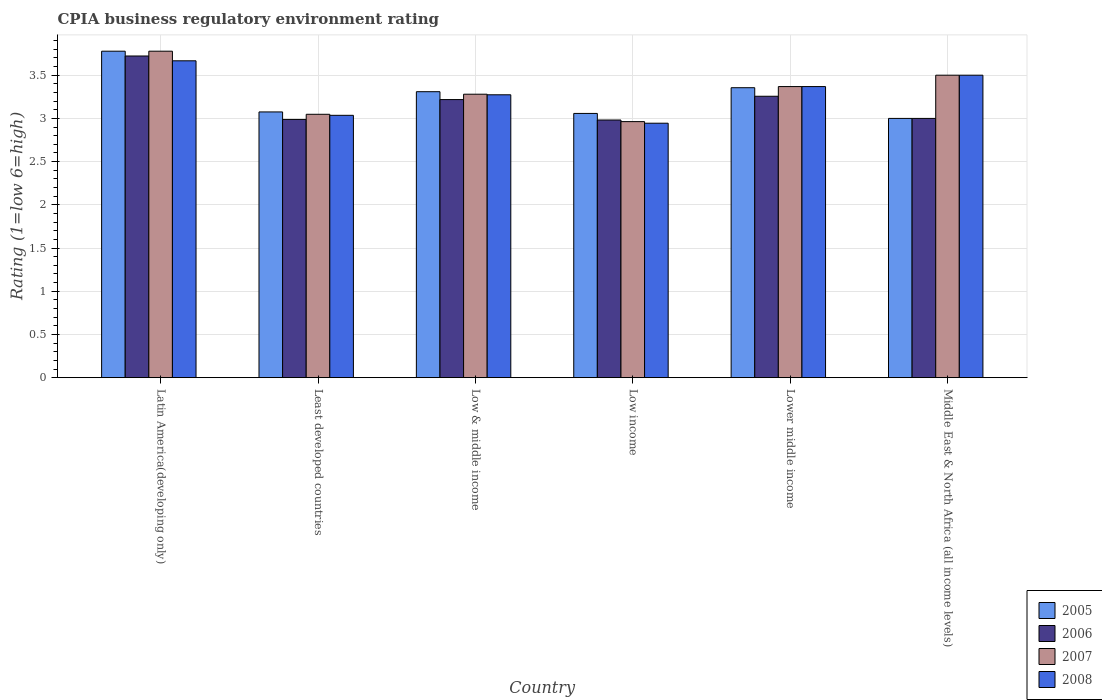How many groups of bars are there?
Your response must be concise. 6. Are the number of bars per tick equal to the number of legend labels?
Provide a succinct answer. Yes. What is the label of the 5th group of bars from the left?
Keep it short and to the point. Lower middle income. Across all countries, what is the maximum CPIA rating in 2006?
Give a very brief answer. 3.72. Across all countries, what is the minimum CPIA rating in 2007?
Ensure brevity in your answer.  2.96. In which country was the CPIA rating in 2005 maximum?
Keep it short and to the point. Latin America(developing only). In which country was the CPIA rating in 2006 minimum?
Offer a very short reply. Low income. What is the total CPIA rating in 2005 in the graph?
Your answer should be compact. 19.57. What is the difference between the CPIA rating in 2007 in Low & middle income and that in Low income?
Offer a very short reply. 0.32. What is the difference between the CPIA rating in 2006 in Middle East & North Africa (all income levels) and the CPIA rating in 2008 in Least developed countries?
Keep it short and to the point. -0.04. What is the average CPIA rating in 2006 per country?
Offer a terse response. 3.19. What is the difference between the CPIA rating of/in 2005 and CPIA rating of/in 2008 in Least developed countries?
Give a very brief answer. 0.04. In how many countries, is the CPIA rating in 2007 greater than 1.3?
Your response must be concise. 6. What is the ratio of the CPIA rating in 2008 in Latin America(developing only) to that in Low & middle income?
Give a very brief answer. 1.12. What is the difference between the highest and the second highest CPIA rating in 2005?
Keep it short and to the point. -0.42. What is the difference between the highest and the lowest CPIA rating in 2007?
Make the answer very short. 0.81. Is the sum of the CPIA rating in 2008 in Low income and Middle East & North Africa (all income levels) greater than the maximum CPIA rating in 2005 across all countries?
Give a very brief answer. Yes. Is it the case that in every country, the sum of the CPIA rating in 2008 and CPIA rating in 2006 is greater than the sum of CPIA rating in 2005 and CPIA rating in 2007?
Offer a terse response. No. Is it the case that in every country, the sum of the CPIA rating in 2007 and CPIA rating in 2005 is greater than the CPIA rating in 2008?
Your answer should be very brief. Yes. How many bars are there?
Your answer should be compact. 24. What is the difference between two consecutive major ticks on the Y-axis?
Your answer should be compact. 0.5. Does the graph contain any zero values?
Your answer should be very brief. No. How are the legend labels stacked?
Provide a succinct answer. Vertical. What is the title of the graph?
Give a very brief answer. CPIA business regulatory environment rating. Does "1965" appear as one of the legend labels in the graph?
Ensure brevity in your answer.  No. What is the label or title of the Y-axis?
Provide a succinct answer. Rating (1=low 6=high). What is the Rating (1=low 6=high) in 2005 in Latin America(developing only)?
Ensure brevity in your answer.  3.78. What is the Rating (1=low 6=high) in 2006 in Latin America(developing only)?
Give a very brief answer. 3.72. What is the Rating (1=low 6=high) of 2007 in Latin America(developing only)?
Offer a terse response. 3.78. What is the Rating (1=low 6=high) in 2008 in Latin America(developing only)?
Provide a short and direct response. 3.67. What is the Rating (1=low 6=high) of 2005 in Least developed countries?
Your answer should be compact. 3.08. What is the Rating (1=low 6=high) in 2006 in Least developed countries?
Your answer should be very brief. 2.99. What is the Rating (1=low 6=high) in 2007 in Least developed countries?
Ensure brevity in your answer.  3.05. What is the Rating (1=low 6=high) in 2008 in Least developed countries?
Your answer should be compact. 3.04. What is the Rating (1=low 6=high) of 2005 in Low & middle income?
Your response must be concise. 3.31. What is the Rating (1=low 6=high) of 2006 in Low & middle income?
Provide a succinct answer. 3.22. What is the Rating (1=low 6=high) in 2007 in Low & middle income?
Your answer should be compact. 3.28. What is the Rating (1=low 6=high) in 2008 in Low & middle income?
Offer a very short reply. 3.27. What is the Rating (1=low 6=high) of 2005 in Low income?
Provide a short and direct response. 3.06. What is the Rating (1=low 6=high) of 2006 in Low income?
Offer a very short reply. 2.98. What is the Rating (1=low 6=high) in 2007 in Low income?
Give a very brief answer. 2.96. What is the Rating (1=low 6=high) of 2008 in Low income?
Ensure brevity in your answer.  2.94. What is the Rating (1=low 6=high) in 2005 in Lower middle income?
Keep it short and to the point. 3.36. What is the Rating (1=low 6=high) in 2006 in Lower middle income?
Offer a terse response. 3.26. What is the Rating (1=low 6=high) of 2007 in Lower middle income?
Your answer should be very brief. 3.37. What is the Rating (1=low 6=high) of 2008 in Lower middle income?
Ensure brevity in your answer.  3.37. What is the Rating (1=low 6=high) in 2005 in Middle East & North Africa (all income levels)?
Offer a terse response. 3. What is the Rating (1=low 6=high) in 2006 in Middle East & North Africa (all income levels)?
Ensure brevity in your answer.  3. What is the Rating (1=low 6=high) of 2007 in Middle East & North Africa (all income levels)?
Offer a very short reply. 3.5. Across all countries, what is the maximum Rating (1=low 6=high) in 2005?
Give a very brief answer. 3.78. Across all countries, what is the maximum Rating (1=low 6=high) of 2006?
Your answer should be very brief. 3.72. Across all countries, what is the maximum Rating (1=low 6=high) of 2007?
Provide a short and direct response. 3.78. Across all countries, what is the maximum Rating (1=low 6=high) of 2008?
Provide a short and direct response. 3.67. Across all countries, what is the minimum Rating (1=low 6=high) in 2005?
Offer a very short reply. 3. Across all countries, what is the minimum Rating (1=low 6=high) in 2006?
Your answer should be compact. 2.98. Across all countries, what is the minimum Rating (1=low 6=high) of 2007?
Make the answer very short. 2.96. Across all countries, what is the minimum Rating (1=low 6=high) of 2008?
Offer a very short reply. 2.94. What is the total Rating (1=low 6=high) in 2005 in the graph?
Your response must be concise. 19.57. What is the total Rating (1=low 6=high) of 2006 in the graph?
Your answer should be compact. 19.17. What is the total Rating (1=low 6=high) of 2007 in the graph?
Provide a short and direct response. 19.94. What is the total Rating (1=low 6=high) of 2008 in the graph?
Give a very brief answer. 19.79. What is the difference between the Rating (1=low 6=high) in 2005 in Latin America(developing only) and that in Least developed countries?
Ensure brevity in your answer.  0.7. What is the difference between the Rating (1=low 6=high) of 2006 in Latin America(developing only) and that in Least developed countries?
Offer a very short reply. 0.73. What is the difference between the Rating (1=low 6=high) in 2007 in Latin America(developing only) and that in Least developed countries?
Your answer should be very brief. 0.73. What is the difference between the Rating (1=low 6=high) of 2008 in Latin America(developing only) and that in Least developed countries?
Provide a succinct answer. 0.63. What is the difference between the Rating (1=low 6=high) of 2005 in Latin America(developing only) and that in Low & middle income?
Give a very brief answer. 0.47. What is the difference between the Rating (1=low 6=high) in 2006 in Latin America(developing only) and that in Low & middle income?
Offer a very short reply. 0.5. What is the difference between the Rating (1=low 6=high) in 2007 in Latin America(developing only) and that in Low & middle income?
Offer a terse response. 0.5. What is the difference between the Rating (1=low 6=high) of 2008 in Latin America(developing only) and that in Low & middle income?
Keep it short and to the point. 0.39. What is the difference between the Rating (1=low 6=high) in 2005 in Latin America(developing only) and that in Low income?
Provide a short and direct response. 0.72. What is the difference between the Rating (1=low 6=high) in 2006 in Latin America(developing only) and that in Low income?
Your response must be concise. 0.74. What is the difference between the Rating (1=low 6=high) of 2007 in Latin America(developing only) and that in Low income?
Keep it short and to the point. 0.81. What is the difference between the Rating (1=low 6=high) in 2008 in Latin America(developing only) and that in Low income?
Give a very brief answer. 0.72. What is the difference between the Rating (1=low 6=high) of 2005 in Latin America(developing only) and that in Lower middle income?
Keep it short and to the point. 0.42. What is the difference between the Rating (1=low 6=high) in 2006 in Latin America(developing only) and that in Lower middle income?
Provide a short and direct response. 0.47. What is the difference between the Rating (1=low 6=high) in 2007 in Latin America(developing only) and that in Lower middle income?
Keep it short and to the point. 0.41. What is the difference between the Rating (1=low 6=high) in 2008 in Latin America(developing only) and that in Lower middle income?
Provide a short and direct response. 0.3. What is the difference between the Rating (1=low 6=high) of 2006 in Latin America(developing only) and that in Middle East & North Africa (all income levels)?
Make the answer very short. 0.72. What is the difference between the Rating (1=low 6=high) of 2007 in Latin America(developing only) and that in Middle East & North Africa (all income levels)?
Ensure brevity in your answer.  0.28. What is the difference between the Rating (1=low 6=high) in 2008 in Latin America(developing only) and that in Middle East & North Africa (all income levels)?
Give a very brief answer. 0.17. What is the difference between the Rating (1=low 6=high) in 2005 in Least developed countries and that in Low & middle income?
Your answer should be very brief. -0.23. What is the difference between the Rating (1=low 6=high) of 2006 in Least developed countries and that in Low & middle income?
Offer a terse response. -0.23. What is the difference between the Rating (1=low 6=high) of 2007 in Least developed countries and that in Low & middle income?
Offer a very short reply. -0.23. What is the difference between the Rating (1=low 6=high) of 2008 in Least developed countries and that in Low & middle income?
Provide a short and direct response. -0.24. What is the difference between the Rating (1=low 6=high) in 2005 in Least developed countries and that in Low income?
Offer a terse response. 0.02. What is the difference between the Rating (1=low 6=high) in 2006 in Least developed countries and that in Low income?
Your answer should be compact. 0.01. What is the difference between the Rating (1=low 6=high) in 2007 in Least developed countries and that in Low income?
Your answer should be very brief. 0.08. What is the difference between the Rating (1=low 6=high) in 2008 in Least developed countries and that in Low income?
Your answer should be compact. 0.09. What is the difference between the Rating (1=low 6=high) of 2005 in Least developed countries and that in Lower middle income?
Your response must be concise. -0.28. What is the difference between the Rating (1=low 6=high) in 2006 in Least developed countries and that in Lower middle income?
Your answer should be compact. -0.27. What is the difference between the Rating (1=low 6=high) of 2007 in Least developed countries and that in Lower middle income?
Keep it short and to the point. -0.32. What is the difference between the Rating (1=low 6=high) in 2008 in Least developed countries and that in Lower middle income?
Ensure brevity in your answer.  -0.33. What is the difference between the Rating (1=low 6=high) of 2005 in Least developed countries and that in Middle East & North Africa (all income levels)?
Make the answer very short. 0.07. What is the difference between the Rating (1=low 6=high) of 2006 in Least developed countries and that in Middle East & North Africa (all income levels)?
Give a very brief answer. -0.01. What is the difference between the Rating (1=low 6=high) in 2007 in Least developed countries and that in Middle East & North Africa (all income levels)?
Make the answer very short. -0.45. What is the difference between the Rating (1=low 6=high) of 2008 in Least developed countries and that in Middle East & North Africa (all income levels)?
Your answer should be compact. -0.46. What is the difference between the Rating (1=low 6=high) of 2005 in Low & middle income and that in Low income?
Make the answer very short. 0.25. What is the difference between the Rating (1=low 6=high) in 2006 in Low & middle income and that in Low income?
Make the answer very short. 0.24. What is the difference between the Rating (1=low 6=high) of 2007 in Low & middle income and that in Low income?
Your answer should be compact. 0.32. What is the difference between the Rating (1=low 6=high) of 2008 in Low & middle income and that in Low income?
Your response must be concise. 0.33. What is the difference between the Rating (1=low 6=high) of 2005 in Low & middle income and that in Lower middle income?
Provide a succinct answer. -0.05. What is the difference between the Rating (1=low 6=high) in 2006 in Low & middle income and that in Lower middle income?
Offer a terse response. -0.04. What is the difference between the Rating (1=low 6=high) of 2007 in Low & middle income and that in Lower middle income?
Your answer should be very brief. -0.09. What is the difference between the Rating (1=low 6=high) in 2008 in Low & middle income and that in Lower middle income?
Provide a short and direct response. -0.1. What is the difference between the Rating (1=low 6=high) of 2005 in Low & middle income and that in Middle East & North Africa (all income levels)?
Provide a short and direct response. 0.31. What is the difference between the Rating (1=low 6=high) of 2006 in Low & middle income and that in Middle East & North Africa (all income levels)?
Make the answer very short. 0.22. What is the difference between the Rating (1=low 6=high) in 2007 in Low & middle income and that in Middle East & North Africa (all income levels)?
Give a very brief answer. -0.22. What is the difference between the Rating (1=low 6=high) of 2008 in Low & middle income and that in Middle East & North Africa (all income levels)?
Make the answer very short. -0.23. What is the difference between the Rating (1=low 6=high) in 2005 in Low income and that in Lower middle income?
Keep it short and to the point. -0.3. What is the difference between the Rating (1=low 6=high) of 2006 in Low income and that in Lower middle income?
Provide a succinct answer. -0.27. What is the difference between the Rating (1=low 6=high) in 2007 in Low income and that in Lower middle income?
Provide a succinct answer. -0.41. What is the difference between the Rating (1=low 6=high) of 2008 in Low income and that in Lower middle income?
Make the answer very short. -0.42. What is the difference between the Rating (1=low 6=high) of 2005 in Low income and that in Middle East & North Africa (all income levels)?
Offer a very short reply. 0.06. What is the difference between the Rating (1=low 6=high) in 2006 in Low income and that in Middle East & North Africa (all income levels)?
Offer a very short reply. -0.02. What is the difference between the Rating (1=low 6=high) in 2007 in Low income and that in Middle East & North Africa (all income levels)?
Provide a short and direct response. -0.54. What is the difference between the Rating (1=low 6=high) in 2008 in Low income and that in Middle East & North Africa (all income levels)?
Offer a terse response. -0.56. What is the difference between the Rating (1=low 6=high) in 2005 in Lower middle income and that in Middle East & North Africa (all income levels)?
Make the answer very short. 0.36. What is the difference between the Rating (1=low 6=high) of 2006 in Lower middle income and that in Middle East & North Africa (all income levels)?
Make the answer very short. 0.26. What is the difference between the Rating (1=low 6=high) in 2007 in Lower middle income and that in Middle East & North Africa (all income levels)?
Your answer should be very brief. -0.13. What is the difference between the Rating (1=low 6=high) in 2008 in Lower middle income and that in Middle East & North Africa (all income levels)?
Your answer should be compact. -0.13. What is the difference between the Rating (1=low 6=high) in 2005 in Latin America(developing only) and the Rating (1=low 6=high) in 2006 in Least developed countries?
Provide a succinct answer. 0.79. What is the difference between the Rating (1=low 6=high) of 2005 in Latin America(developing only) and the Rating (1=low 6=high) of 2007 in Least developed countries?
Offer a terse response. 0.73. What is the difference between the Rating (1=low 6=high) in 2005 in Latin America(developing only) and the Rating (1=low 6=high) in 2008 in Least developed countries?
Your response must be concise. 0.74. What is the difference between the Rating (1=low 6=high) of 2006 in Latin America(developing only) and the Rating (1=low 6=high) of 2007 in Least developed countries?
Provide a short and direct response. 0.67. What is the difference between the Rating (1=low 6=high) of 2006 in Latin America(developing only) and the Rating (1=low 6=high) of 2008 in Least developed countries?
Offer a terse response. 0.69. What is the difference between the Rating (1=low 6=high) of 2007 in Latin America(developing only) and the Rating (1=low 6=high) of 2008 in Least developed countries?
Your response must be concise. 0.74. What is the difference between the Rating (1=low 6=high) of 2005 in Latin America(developing only) and the Rating (1=low 6=high) of 2006 in Low & middle income?
Keep it short and to the point. 0.56. What is the difference between the Rating (1=low 6=high) in 2005 in Latin America(developing only) and the Rating (1=low 6=high) in 2007 in Low & middle income?
Offer a terse response. 0.5. What is the difference between the Rating (1=low 6=high) in 2005 in Latin America(developing only) and the Rating (1=low 6=high) in 2008 in Low & middle income?
Your response must be concise. 0.5. What is the difference between the Rating (1=low 6=high) of 2006 in Latin America(developing only) and the Rating (1=low 6=high) of 2007 in Low & middle income?
Your response must be concise. 0.44. What is the difference between the Rating (1=low 6=high) of 2006 in Latin America(developing only) and the Rating (1=low 6=high) of 2008 in Low & middle income?
Provide a short and direct response. 0.45. What is the difference between the Rating (1=low 6=high) in 2007 in Latin America(developing only) and the Rating (1=low 6=high) in 2008 in Low & middle income?
Give a very brief answer. 0.5. What is the difference between the Rating (1=low 6=high) of 2005 in Latin America(developing only) and the Rating (1=low 6=high) of 2006 in Low income?
Offer a very short reply. 0.8. What is the difference between the Rating (1=low 6=high) of 2005 in Latin America(developing only) and the Rating (1=low 6=high) of 2007 in Low income?
Offer a terse response. 0.81. What is the difference between the Rating (1=low 6=high) in 2006 in Latin America(developing only) and the Rating (1=low 6=high) in 2007 in Low income?
Your answer should be compact. 0.76. What is the difference between the Rating (1=low 6=high) of 2007 in Latin America(developing only) and the Rating (1=low 6=high) of 2008 in Low income?
Offer a very short reply. 0.83. What is the difference between the Rating (1=low 6=high) of 2005 in Latin America(developing only) and the Rating (1=low 6=high) of 2006 in Lower middle income?
Offer a terse response. 0.52. What is the difference between the Rating (1=low 6=high) of 2005 in Latin America(developing only) and the Rating (1=low 6=high) of 2007 in Lower middle income?
Your answer should be compact. 0.41. What is the difference between the Rating (1=low 6=high) in 2005 in Latin America(developing only) and the Rating (1=low 6=high) in 2008 in Lower middle income?
Your response must be concise. 0.41. What is the difference between the Rating (1=low 6=high) in 2006 in Latin America(developing only) and the Rating (1=low 6=high) in 2007 in Lower middle income?
Your answer should be very brief. 0.35. What is the difference between the Rating (1=low 6=high) of 2006 in Latin America(developing only) and the Rating (1=low 6=high) of 2008 in Lower middle income?
Give a very brief answer. 0.35. What is the difference between the Rating (1=low 6=high) of 2007 in Latin America(developing only) and the Rating (1=low 6=high) of 2008 in Lower middle income?
Provide a succinct answer. 0.41. What is the difference between the Rating (1=low 6=high) of 2005 in Latin America(developing only) and the Rating (1=low 6=high) of 2006 in Middle East & North Africa (all income levels)?
Make the answer very short. 0.78. What is the difference between the Rating (1=low 6=high) of 2005 in Latin America(developing only) and the Rating (1=low 6=high) of 2007 in Middle East & North Africa (all income levels)?
Give a very brief answer. 0.28. What is the difference between the Rating (1=low 6=high) in 2005 in Latin America(developing only) and the Rating (1=low 6=high) in 2008 in Middle East & North Africa (all income levels)?
Give a very brief answer. 0.28. What is the difference between the Rating (1=low 6=high) in 2006 in Latin America(developing only) and the Rating (1=low 6=high) in 2007 in Middle East & North Africa (all income levels)?
Keep it short and to the point. 0.22. What is the difference between the Rating (1=low 6=high) of 2006 in Latin America(developing only) and the Rating (1=low 6=high) of 2008 in Middle East & North Africa (all income levels)?
Offer a very short reply. 0.22. What is the difference between the Rating (1=low 6=high) of 2007 in Latin America(developing only) and the Rating (1=low 6=high) of 2008 in Middle East & North Africa (all income levels)?
Your answer should be compact. 0.28. What is the difference between the Rating (1=low 6=high) in 2005 in Least developed countries and the Rating (1=low 6=high) in 2006 in Low & middle income?
Your response must be concise. -0.14. What is the difference between the Rating (1=low 6=high) of 2005 in Least developed countries and the Rating (1=low 6=high) of 2007 in Low & middle income?
Ensure brevity in your answer.  -0.2. What is the difference between the Rating (1=low 6=high) of 2005 in Least developed countries and the Rating (1=low 6=high) of 2008 in Low & middle income?
Your response must be concise. -0.2. What is the difference between the Rating (1=low 6=high) in 2006 in Least developed countries and the Rating (1=low 6=high) in 2007 in Low & middle income?
Offer a terse response. -0.29. What is the difference between the Rating (1=low 6=high) in 2006 in Least developed countries and the Rating (1=low 6=high) in 2008 in Low & middle income?
Provide a succinct answer. -0.29. What is the difference between the Rating (1=low 6=high) of 2007 in Least developed countries and the Rating (1=low 6=high) of 2008 in Low & middle income?
Keep it short and to the point. -0.23. What is the difference between the Rating (1=low 6=high) in 2005 in Least developed countries and the Rating (1=low 6=high) in 2006 in Low income?
Make the answer very short. 0.09. What is the difference between the Rating (1=low 6=high) of 2005 in Least developed countries and the Rating (1=low 6=high) of 2007 in Low income?
Your answer should be very brief. 0.11. What is the difference between the Rating (1=low 6=high) in 2005 in Least developed countries and the Rating (1=low 6=high) in 2008 in Low income?
Offer a terse response. 0.13. What is the difference between the Rating (1=low 6=high) of 2006 in Least developed countries and the Rating (1=low 6=high) of 2007 in Low income?
Make the answer very short. 0.03. What is the difference between the Rating (1=low 6=high) in 2006 in Least developed countries and the Rating (1=low 6=high) in 2008 in Low income?
Keep it short and to the point. 0.04. What is the difference between the Rating (1=low 6=high) of 2007 in Least developed countries and the Rating (1=low 6=high) of 2008 in Low income?
Provide a succinct answer. 0.1. What is the difference between the Rating (1=low 6=high) in 2005 in Least developed countries and the Rating (1=low 6=high) in 2006 in Lower middle income?
Provide a succinct answer. -0.18. What is the difference between the Rating (1=low 6=high) in 2005 in Least developed countries and the Rating (1=low 6=high) in 2007 in Lower middle income?
Provide a succinct answer. -0.29. What is the difference between the Rating (1=low 6=high) in 2005 in Least developed countries and the Rating (1=low 6=high) in 2008 in Lower middle income?
Provide a succinct answer. -0.29. What is the difference between the Rating (1=low 6=high) in 2006 in Least developed countries and the Rating (1=low 6=high) in 2007 in Lower middle income?
Give a very brief answer. -0.38. What is the difference between the Rating (1=low 6=high) of 2006 in Least developed countries and the Rating (1=low 6=high) of 2008 in Lower middle income?
Offer a terse response. -0.38. What is the difference between the Rating (1=low 6=high) of 2007 in Least developed countries and the Rating (1=low 6=high) of 2008 in Lower middle income?
Make the answer very short. -0.32. What is the difference between the Rating (1=low 6=high) of 2005 in Least developed countries and the Rating (1=low 6=high) of 2006 in Middle East & North Africa (all income levels)?
Provide a succinct answer. 0.07. What is the difference between the Rating (1=low 6=high) in 2005 in Least developed countries and the Rating (1=low 6=high) in 2007 in Middle East & North Africa (all income levels)?
Make the answer very short. -0.42. What is the difference between the Rating (1=low 6=high) in 2005 in Least developed countries and the Rating (1=low 6=high) in 2008 in Middle East & North Africa (all income levels)?
Make the answer very short. -0.42. What is the difference between the Rating (1=low 6=high) in 2006 in Least developed countries and the Rating (1=low 6=high) in 2007 in Middle East & North Africa (all income levels)?
Ensure brevity in your answer.  -0.51. What is the difference between the Rating (1=low 6=high) in 2006 in Least developed countries and the Rating (1=low 6=high) in 2008 in Middle East & North Africa (all income levels)?
Your response must be concise. -0.51. What is the difference between the Rating (1=low 6=high) of 2007 in Least developed countries and the Rating (1=low 6=high) of 2008 in Middle East & North Africa (all income levels)?
Your response must be concise. -0.45. What is the difference between the Rating (1=low 6=high) of 2005 in Low & middle income and the Rating (1=low 6=high) of 2006 in Low income?
Your response must be concise. 0.33. What is the difference between the Rating (1=low 6=high) of 2005 in Low & middle income and the Rating (1=low 6=high) of 2007 in Low income?
Ensure brevity in your answer.  0.35. What is the difference between the Rating (1=low 6=high) in 2005 in Low & middle income and the Rating (1=low 6=high) in 2008 in Low income?
Keep it short and to the point. 0.36. What is the difference between the Rating (1=low 6=high) in 2006 in Low & middle income and the Rating (1=low 6=high) in 2007 in Low income?
Give a very brief answer. 0.26. What is the difference between the Rating (1=low 6=high) in 2006 in Low & middle income and the Rating (1=low 6=high) in 2008 in Low income?
Provide a short and direct response. 0.27. What is the difference between the Rating (1=low 6=high) of 2007 in Low & middle income and the Rating (1=low 6=high) of 2008 in Low income?
Your answer should be very brief. 0.34. What is the difference between the Rating (1=low 6=high) in 2005 in Low & middle income and the Rating (1=low 6=high) in 2006 in Lower middle income?
Your answer should be very brief. 0.05. What is the difference between the Rating (1=low 6=high) in 2005 in Low & middle income and the Rating (1=low 6=high) in 2007 in Lower middle income?
Make the answer very short. -0.06. What is the difference between the Rating (1=low 6=high) in 2005 in Low & middle income and the Rating (1=low 6=high) in 2008 in Lower middle income?
Provide a succinct answer. -0.06. What is the difference between the Rating (1=low 6=high) in 2006 in Low & middle income and the Rating (1=low 6=high) in 2007 in Lower middle income?
Your answer should be very brief. -0.15. What is the difference between the Rating (1=low 6=high) of 2006 in Low & middle income and the Rating (1=low 6=high) of 2008 in Lower middle income?
Give a very brief answer. -0.15. What is the difference between the Rating (1=low 6=high) of 2007 in Low & middle income and the Rating (1=low 6=high) of 2008 in Lower middle income?
Offer a very short reply. -0.09. What is the difference between the Rating (1=low 6=high) of 2005 in Low & middle income and the Rating (1=low 6=high) of 2006 in Middle East & North Africa (all income levels)?
Offer a very short reply. 0.31. What is the difference between the Rating (1=low 6=high) in 2005 in Low & middle income and the Rating (1=low 6=high) in 2007 in Middle East & North Africa (all income levels)?
Offer a very short reply. -0.19. What is the difference between the Rating (1=low 6=high) of 2005 in Low & middle income and the Rating (1=low 6=high) of 2008 in Middle East & North Africa (all income levels)?
Offer a terse response. -0.19. What is the difference between the Rating (1=low 6=high) in 2006 in Low & middle income and the Rating (1=low 6=high) in 2007 in Middle East & North Africa (all income levels)?
Make the answer very short. -0.28. What is the difference between the Rating (1=low 6=high) of 2006 in Low & middle income and the Rating (1=low 6=high) of 2008 in Middle East & North Africa (all income levels)?
Your answer should be compact. -0.28. What is the difference between the Rating (1=low 6=high) in 2007 in Low & middle income and the Rating (1=low 6=high) in 2008 in Middle East & North Africa (all income levels)?
Offer a terse response. -0.22. What is the difference between the Rating (1=low 6=high) in 2005 in Low income and the Rating (1=low 6=high) in 2006 in Lower middle income?
Ensure brevity in your answer.  -0.2. What is the difference between the Rating (1=low 6=high) in 2005 in Low income and the Rating (1=low 6=high) in 2007 in Lower middle income?
Your answer should be very brief. -0.31. What is the difference between the Rating (1=low 6=high) of 2005 in Low income and the Rating (1=low 6=high) of 2008 in Lower middle income?
Ensure brevity in your answer.  -0.31. What is the difference between the Rating (1=low 6=high) in 2006 in Low income and the Rating (1=low 6=high) in 2007 in Lower middle income?
Offer a very short reply. -0.39. What is the difference between the Rating (1=low 6=high) in 2006 in Low income and the Rating (1=low 6=high) in 2008 in Lower middle income?
Provide a succinct answer. -0.39. What is the difference between the Rating (1=low 6=high) of 2007 in Low income and the Rating (1=low 6=high) of 2008 in Lower middle income?
Keep it short and to the point. -0.41. What is the difference between the Rating (1=low 6=high) in 2005 in Low income and the Rating (1=low 6=high) in 2006 in Middle East & North Africa (all income levels)?
Your answer should be compact. 0.06. What is the difference between the Rating (1=low 6=high) of 2005 in Low income and the Rating (1=low 6=high) of 2007 in Middle East & North Africa (all income levels)?
Your response must be concise. -0.44. What is the difference between the Rating (1=low 6=high) in 2005 in Low income and the Rating (1=low 6=high) in 2008 in Middle East & North Africa (all income levels)?
Offer a terse response. -0.44. What is the difference between the Rating (1=low 6=high) in 2006 in Low income and the Rating (1=low 6=high) in 2007 in Middle East & North Africa (all income levels)?
Provide a succinct answer. -0.52. What is the difference between the Rating (1=low 6=high) of 2006 in Low income and the Rating (1=low 6=high) of 2008 in Middle East & North Africa (all income levels)?
Ensure brevity in your answer.  -0.52. What is the difference between the Rating (1=low 6=high) in 2007 in Low income and the Rating (1=low 6=high) in 2008 in Middle East & North Africa (all income levels)?
Give a very brief answer. -0.54. What is the difference between the Rating (1=low 6=high) of 2005 in Lower middle income and the Rating (1=low 6=high) of 2006 in Middle East & North Africa (all income levels)?
Your answer should be compact. 0.36. What is the difference between the Rating (1=low 6=high) in 2005 in Lower middle income and the Rating (1=low 6=high) in 2007 in Middle East & North Africa (all income levels)?
Give a very brief answer. -0.14. What is the difference between the Rating (1=low 6=high) in 2005 in Lower middle income and the Rating (1=low 6=high) in 2008 in Middle East & North Africa (all income levels)?
Your answer should be compact. -0.14. What is the difference between the Rating (1=low 6=high) in 2006 in Lower middle income and the Rating (1=low 6=high) in 2007 in Middle East & North Africa (all income levels)?
Ensure brevity in your answer.  -0.24. What is the difference between the Rating (1=low 6=high) in 2006 in Lower middle income and the Rating (1=low 6=high) in 2008 in Middle East & North Africa (all income levels)?
Your answer should be very brief. -0.24. What is the difference between the Rating (1=low 6=high) in 2007 in Lower middle income and the Rating (1=low 6=high) in 2008 in Middle East & North Africa (all income levels)?
Your answer should be compact. -0.13. What is the average Rating (1=low 6=high) of 2005 per country?
Ensure brevity in your answer.  3.26. What is the average Rating (1=low 6=high) in 2006 per country?
Your response must be concise. 3.19. What is the average Rating (1=low 6=high) of 2007 per country?
Your answer should be very brief. 3.32. What is the average Rating (1=low 6=high) in 2008 per country?
Ensure brevity in your answer.  3.3. What is the difference between the Rating (1=low 6=high) of 2005 and Rating (1=low 6=high) of 2006 in Latin America(developing only)?
Keep it short and to the point. 0.06. What is the difference between the Rating (1=low 6=high) in 2006 and Rating (1=low 6=high) in 2007 in Latin America(developing only)?
Your answer should be compact. -0.06. What is the difference between the Rating (1=low 6=high) in 2006 and Rating (1=low 6=high) in 2008 in Latin America(developing only)?
Make the answer very short. 0.06. What is the difference between the Rating (1=low 6=high) in 2007 and Rating (1=low 6=high) in 2008 in Latin America(developing only)?
Keep it short and to the point. 0.11. What is the difference between the Rating (1=low 6=high) of 2005 and Rating (1=low 6=high) of 2006 in Least developed countries?
Make the answer very short. 0.09. What is the difference between the Rating (1=low 6=high) of 2005 and Rating (1=low 6=high) of 2007 in Least developed countries?
Your answer should be compact. 0.03. What is the difference between the Rating (1=low 6=high) in 2005 and Rating (1=low 6=high) in 2008 in Least developed countries?
Your answer should be very brief. 0.04. What is the difference between the Rating (1=low 6=high) in 2006 and Rating (1=low 6=high) in 2007 in Least developed countries?
Provide a succinct answer. -0.06. What is the difference between the Rating (1=low 6=high) in 2006 and Rating (1=low 6=high) in 2008 in Least developed countries?
Provide a succinct answer. -0.05. What is the difference between the Rating (1=low 6=high) in 2007 and Rating (1=low 6=high) in 2008 in Least developed countries?
Ensure brevity in your answer.  0.01. What is the difference between the Rating (1=low 6=high) in 2005 and Rating (1=low 6=high) in 2006 in Low & middle income?
Keep it short and to the point. 0.09. What is the difference between the Rating (1=low 6=high) of 2005 and Rating (1=low 6=high) of 2007 in Low & middle income?
Ensure brevity in your answer.  0.03. What is the difference between the Rating (1=low 6=high) in 2005 and Rating (1=low 6=high) in 2008 in Low & middle income?
Keep it short and to the point. 0.04. What is the difference between the Rating (1=low 6=high) of 2006 and Rating (1=low 6=high) of 2007 in Low & middle income?
Make the answer very short. -0.06. What is the difference between the Rating (1=low 6=high) in 2006 and Rating (1=low 6=high) in 2008 in Low & middle income?
Provide a succinct answer. -0.06. What is the difference between the Rating (1=low 6=high) in 2007 and Rating (1=low 6=high) in 2008 in Low & middle income?
Your response must be concise. 0.01. What is the difference between the Rating (1=low 6=high) in 2005 and Rating (1=low 6=high) in 2006 in Low income?
Provide a succinct answer. 0.08. What is the difference between the Rating (1=low 6=high) in 2005 and Rating (1=low 6=high) in 2007 in Low income?
Keep it short and to the point. 0.09. What is the difference between the Rating (1=low 6=high) of 2005 and Rating (1=low 6=high) of 2008 in Low income?
Give a very brief answer. 0.11. What is the difference between the Rating (1=low 6=high) of 2006 and Rating (1=low 6=high) of 2007 in Low income?
Your answer should be compact. 0.02. What is the difference between the Rating (1=low 6=high) of 2006 and Rating (1=low 6=high) of 2008 in Low income?
Offer a terse response. 0.04. What is the difference between the Rating (1=low 6=high) in 2007 and Rating (1=low 6=high) in 2008 in Low income?
Ensure brevity in your answer.  0.02. What is the difference between the Rating (1=low 6=high) in 2005 and Rating (1=low 6=high) in 2006 in Lower middle income?
Give a very brief answer. 0.1. What is the difference between the Rating (1=low 6=high) in 2005 and Rating (1=low 6=high) in 2007 in Lower middle income?
Your answer should be very brief. -0.01. What is the difference between the Rating (1=low 6=high) of 2005 and Rating (1=low 6=high) of 2008 in Lower middle income?
Your answer should be very brief. -0.01. What is the difference between the Rating (1=low 6=high) in 2006 and Rating (1=low 6=high) in 2007 in Lower middle income?
Your answer should be compact. -0.11. What is the difference between the Rating (1=low 6=high) of 2006 and Rating (1=low 6=high) of 2008 in Lower middle income?
Provide a short and direct response. -0.11. What is the difference between the Rating (1=low 6=high) in 2007 and Rating (1=low 6=high) in 2008 in Lower middle income?
Your answer should be very brief. 0. What is the difference between the Rating (1=low 6=high) in 2005 and Rating (1=low 6=high) in 2006 in Middle East & North Africa (all income levels)?
Provide a short and direct response. 0. What is the difference between the Rating (1=low 6=high) in 2005 and Rating (1=low 6=high) in 2008 in Middle East & North Africa (all income levels)?
Provide a short and direct response. -0.5. What is the ratio of the Rating (1=low 6=high) in 2005 in Latin America(developing only) to that in Least developed countries?
Your response must be concise. 1.23. What is the ratio of the Rating (1=low 6=high) in 2006 in Latin America(developing only) to that in Least developed countries?
Keep it short and to the point. 1.25. What is the ratio of the Rating (1=low 6=high) in 2007 in Latin America(developing only) to that in Least developed countries?
Offer a very short reply. 1.24. What is the ratio of the Rating (1=low 6=high) in 2008 in Latin America(developing only) to that in Least developed countries?
Offer a terse response. 1.21. What is the ratio of the Rating (1=low 6=high) in 2005 in Latin America(developing only) to that in Low & middle income?
Your answer should be compact. 1.14. What is the ratio of the Rating (1=low 6=high) in 2006 in Latin America(developing only) to that in Low & middle income?
Ensure brevity in your answer.  1.16. What is the ratio of the Rating (1=low 6=high) in 2007 in Latin America(developing only) to that in Low & middle income?
Give a very brief answer. 1.15. What is the ratio of the Rating (1=low 6=high) of 2008 in Latin America(developing only) to that in Low & middle income?
Offer a very short reply. 1.12. What is the ratio of the Rating (1=low 6=high) in 2005 in Latin America(developing only) to that in Low income?
Your answer should be compact. 1.24. What is the ratio of the Rating (1=low 6=high) in 2006 in Latin America(developing only) to that in Low income?
Provide a succinct answer. 1.25. What is the ratio of the Rating (1=low 6=high) in 2007 in Latin America(developing only) to that in Low income?
Ensure brevity in your answer.  1.27. What is the ratio of the Rating (1=low 6=high) of 2008 in Latin America(developing only) to that in Low income?
Give a very brief answer. 1.25. What is the ratio of the Rating (1=low 6=high) in 2005 in Latin America(developing only) to that in Lower middle income?
Offer a terse response. 1.13. What is the ratio of the Rating (1=low 6=high) of 2006 in Latin America(developing only) to that in Lower middle income?
Offer a terse response. 1.14. What is the ratio of the Rating (1=low 6=high) of 2007 in Latin America(developing only) to that in Lower middle income?
Provide a short and direct response. 1.12. What is the ratio of the Rating (1=low 6=high) in 2008 in Latin America(developing only) to that in Lower middle income?
Give a very brief answer. 1.09. What is the ratio of the Rating (1=low 6=high) in 2005 in Latin America(developing only) to that in Middle East & North Africa (all income levels)?
Ensure brevity in your answer.  1.26. What is the ratio of the Rating (1=low 6=high) in 2006 in Latin America(developing only) to that in Middle East & North Africa (all income levels)?
Make the answer very short. 1.24. What is the ratio of the Rating (1=low 6=high) of 2007 in Latin America(developing only) to that in Middle East & North Africa (all income levels)?
Provide a succinct answer. 1.08. What is the ratio of the Rating (1=low 6=high) in 2008 in Latin America(developing only) to that in Middle East & North Africa (all income levels)?
Offer a very short reply. 1.05. What is the ratio of the Rating (1=low 6=high) of 2005 in Least developed countries to that in Low & middle income?
Keep it short and to the point. 0.93. What is the ratio of the Rating (1=low 6=high) in 2006 in Least developed countries to that in Low & middle income?
Keep it short and to the point. 0.93. What is the ratio of the Rating (1=low 6=high) in 2007 in Least developed countries to that in Low & middle income?
Make the answer very short. 0.93. What is the ratio of the Rating (1=low 6=high) of 2008 in Least developed countries to that in Low & middle income?
Your answer should be very brief. 0.93. What is the ratio of the Rating (1=low 6=high) of 2007 in Least developed countries to that in Low income?
Offer a terse response. 1.03. What is the ratio of the Rating (1=low 6=high) in 2008 in Least developed countries to that in Low income?
Keep it short and to the point. 1.03. What is the ratio of the Rating (1=low 6=high) of 2005 in Least developed countries to that in Lower middle income?
Your answer should be compact. 0.92. What is the ratio of the Rating (1=low 6=high) in 2006 in Least developed countries to that in Lower middle income?
Give a very brief answer. 0.92. What is the ratio of the Rating (1=low 6=high) of 2007 in Least developed countries to that in Lower middle income?
Offer a very short reply. 0.9. What is the ratio of the Rating (1=low 6=high) of 2008 in Least developed countries to that in Lower middle income?
Your response must be concise. 0.9. What is the ratio of the Rating (1=low 6=high) of 2007 in Least developed countries to that in Middle East & North Africa (all income levels)?
Offer a very short reply. 0.87. What is the ratio of the Rating (1=low 6=high) of 2008 in Least developed countries to that in Middle East & North Africa (all income levels)?
Offer a terse response. 0.87. What is the ratio of the Rating (1=low 6=high) in 2005 in Low & middle income to that in Low income?
Ensure brevity in your answer.  1.08. What is the ratio of the Rating (1=low 6=high) in 2006 in Low & middle income to that in Low income?
Give a very brief answer. 1.08. What is the ratio of the Rating (1=low 6=high) of 2007 in Low & middle income to that in Low income?
Provide a short and direct response. 1.11. What is the ratio of the Rating (1=low 6=high) in 2008 in Low & middle income to that in Low income?
Provide a succinct answer. 1.11. What is the ratio of the Rating (1=low 6=high) of 2005 in Low & middle income to that in Lower middle income?
Your answer should be compact. 0.99. What is the ratio of the Rating (1=low 6=high) in 2006 in Low & middle income to that in Lower middle income?
Keep it short and to the point. 0.99. What is the ratio of the Rating (1=low 6=high) of 2007 in Low & middle income to that in Lower middle income?
Keep it short and to the point. 0.97. What is the ratio of the Rating (1=low 6=high) in 2008 in Low & middle income to that in Lower middle income?
Make the answer very short. 0.97. What is the ratio of the Rating (1=low 6=high) of 2005 in Low & middle income to that in Middle East & North Africa (all income levels)?
Make the answer very short. 1.1. What is the ratio of the Rating (1=low 6=high) in 2006 in Low & middle income to that in Middle East & North Africa (all income levels)?
Give a very brief answer. 1.07. What is the ratio of the Rating (1=low 6=high) of 2007 in Low & middle income to that in Middle East & North Africa (all income levels)?
Your answer should be very brief. 0.94. What is the ratio of the Rating (1=low 6=high) of 2008 in Low & middle income to that in Middle East & North Africa (all income levels)?
Ensure brevity in your answer.  0.94. What is the ratio of the Rating (1=low 6=high) of 2005 in Low income to that in Lower middle income?
Your answer should be very brief. 0.91. What is the ratio of the Rating (1=low 6=high) of 2006 in Low income to that in Lower middle income?
Make the answer very short. 0.92. What is the ratio of the Rating (1=low 6=high) of 2007 in Low income to that in Lower middle income?
Your answer should be compact. 0.88. What is the ratio of the Rating (1=low 6=high) of 2008 in Low income to that in Lower middle income?
Provide a short and direct response. 0.87. What is the ratio of the Rating (1=low 6=high) of 2005 in Low income to that in Middle East & North Africa (all income levels)?
Keep it short and to the point. 1.02. What is the ratio of the Rating (1=low 6=high) of 2006 in Low income to that in Middle East & North Africa (all income levels)?
Make the answer very short. 0.99. What is the ratio of the Rating (1=low 6=high) in 2007 in Low income to that in Middle East & North Africa (all income levels)?
Ensure brevity in your answer.  0.85. What is the ratio of the Rating (1=low 6=high) of 2008 in Low income to that in Middle East & North Africa (all income levels)?
Offer a very short reply. 0.84. What is the ratio of the Rating (1=low 6=high) in 2005 in Lower middle income to that in Middle East & North Africa (all income levels)?
Your response must be concise. 1.12. What is the ratio of the Rating (1=low 6=high) of 2006 in Lower middle income to that in Middle East & North Africa (all income levels)?
Offer a very short reply. 1.09. What is the ratio of the Rating (1=low 6=high) of 2007 in Lower middle income to that in Middle East & North Africa (all income levels)?
Offer a very short reply. 0.96. What is the ratio of the Rating (1=low 6=high) of 2008 in Lower middle income to that in Middle East & North Africa (all income levels)?
Make the answer very short. 0.96. What is the difference between the highest and the second highest Rating (1=low 6=high) in 2005?
Offer a terse response. 0.42. What is the difference between the highest and the second highest Rating (1=low 6=high) in 2006?
Your answer should be compact. 0.47. What is the difference between the highest and the second highest Rating (1=low 6=high) in 2007?
Your response must be concise. 0.28. What is the difference between the highest and the second highest Rating (1=low 6=high) of 2008?
Your response must be concise. 0.17. What is the difference between the highest and the lowest Rating (1=low 6=high) in 2006?
Your response must be concise. 0.74. What is the difference between the highest and the lowest Rating (1=low 6=high) in 2007?
Provide a succinct answer. 0.81. What is the difference between the highest and the lowest Rating (1=low 6=high) in 2008?
Offer a terse response. 0.72. 